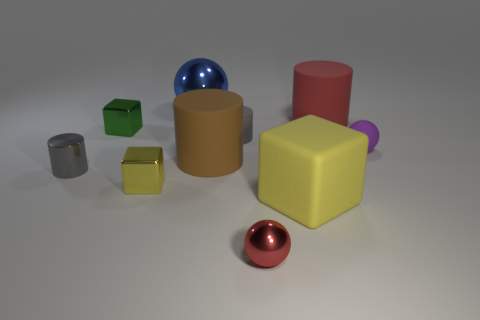Subtract all metallic balls. How many balls are left? 1 Subtract all green spheres. How many yellow blocks are left? 2 Subtract 1 spheres. How many spheres are left? 2 Subtract all gray cylinders. How many cylinders are left? 2 Subtract all green spheres. Subtract all yellow cylinders. How many spheres are left? 3 Subtract all cubes. How many objects are left? 7 Add 9 red balls. How many red balls exist? 10 Subtract 1 blue balls. How many objects are left? 9 Subtract all gray cylinders. Subtract all red objects. How many objects are left? 6 Add 6 blue balls. How many blue balls are left? 7 